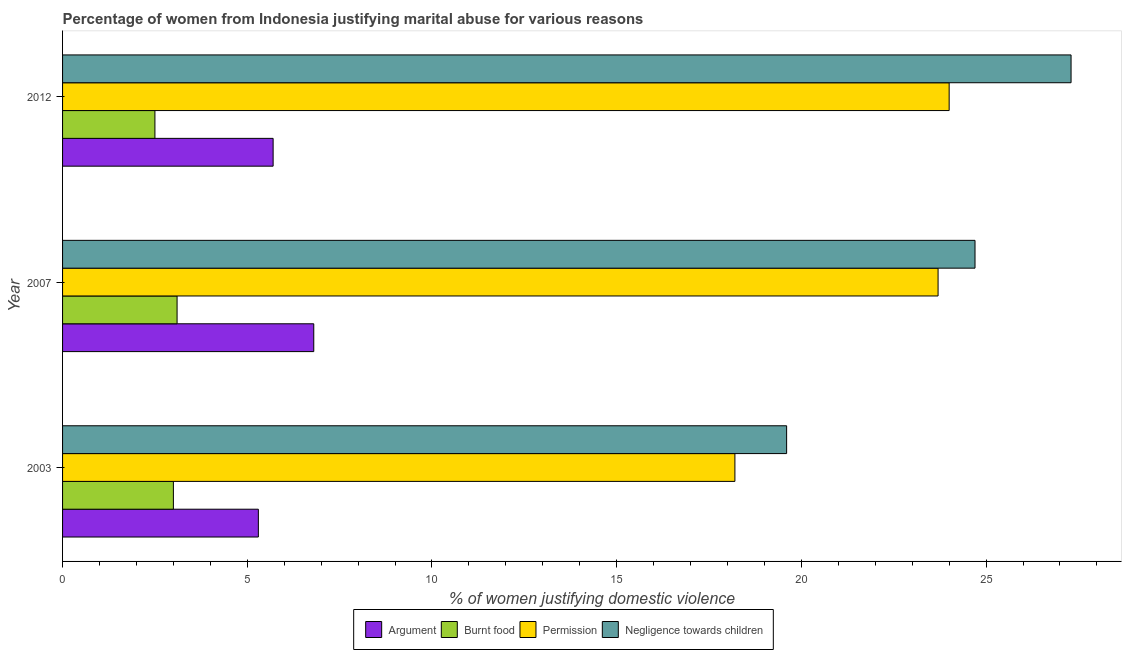How many different coloured bars are there?
Your answer should be compact. 4. Are the number of bars on each tick of the Y-axis equal?
Provide a short and direct response. Yes. What is the percentage of women justifying abuse in the case of an argument in 2012?
Make the answer very short. 5.7. Across all years, what is the maximum percentage of women justifying abuse for showing negligence towards children?
Provide a short and direct response. 27.3. Across all years, what is the minimum percentage of women justifying abuse for showing negligence towards children?
Give a very brief answer. 19.6. In which year was the percentage of women justifying abuse for burning food maximum?
Give a very brief answer. 2007. In which year was the percentage of women justifying abuse for going without permission minimum?
Provide a succinct answer. 2003. What is the total percentage of women justifying abuse for showing negligence towards children in the graph?
Offer a very short reply. 71.6. What is the difference between the percentage of women justifying abuse in the case of an argument in 2003 and that in 2007?
Your answer should be very brief. -1.5. What is the average percentage of women justifying abuse for burning food per year?
Offer a very short reply. 2.87. In the year 2007, what is the difference between the percentage of women justifying abuse in the case of an argument and percentage of women justifying abuse for going without permission?
Provide a short and direct response. -16.9. What is the ratio of the percentage of women justifying abuse for showing negligence towards children in 2003 to that in 2007?
Ensure brevity in your answer.  0.79. Is the difference between the percentage of women justifying abuse for showing negligence towards children in 2003 and 2007 greater than the difference between the percentage of women justifying abuse in the case of an argument in 2003 and 2007?
Your answer should be very brief. No. What is the difference between the highest and the second highest percentage of women justifying abuse in the case of an argument?
Give a very brief answer. 1.1. What is the difference between the highest and the lowest percentage of women justifying abuse for showing negligence towards children?
Provide a short and direct response. 7.7. In how many years, is the percentage of women justifying abuse in the case of an argument greater than the average percentage of women justifying abuse in the case of an argument taken over all years?
Offer a very short reply. 1. Is the sum of the percentage of women justifying abuse for going without permission in 2007 and 2012 greater than the maximum percentage of women justifying abuse in the case of an argument across all years?
Offer a terse response. Yes. What does the 3rd bar from the top in 2012 represents?
Keep it short and to the point. Burnt food. What does the 2nd bar from the bottom in 2003 represents?
Keep it short and to the point. Burnt food. Is it the case that in every year, the sum of the percentage of women justifying abuse in the case of an argument and percentage of women justifying abuse for burning food is greater than the percentage of women justifying abuse for going without permission?
Make the answer very short. No. How many bars are there?
Offer a very short reply. 12. Are all the bars in the graph horizontal?
Your response must be concise. Yes. Are the values on the major ticks of X-axis written in scientific E-notation?
Make the answer very short. No. Does the graph contain grids?
Your answer should be compact. No. Where does the legend appear in the graph?
Offer a terse response. Bottom center. What is the title of the graph?
Ensure brevity in your answer.  Percentage of women from Indonesia justifying marital abuse for various reasons. What is the label or title of the X-axis?
Make the answer very short. % of women justifying domestic violence. What is the % of women justifying domestic violence in Permission in 2003?
Your response must be concise. 18.2. What is the % of women justifying domestic violence in Negligence towards children in 2003?
Your response must be concise. 19.6. What is the % of women justifying domestic violence in Argument in 2007?
Keep it short and to the point. 6.8. What is the % of women justifying domestic violence in Permission in 2007?
Offer a terse response. 23.7. What is the % of women justifying domestic violence in Negligence towards children in 2007?
Keep it short and to the point. 24.7. What is the % of women justifying domestic violence in Permission in 2012?
Give a very brief answer. 24. What is the % of women justifying domestic violence of Negligence towards children in 2012?
Provide a succinct answer. 27.3. Across all years, what is the maximum % of women justifying domestic violence of Burnt food?
Keep it short and to the point. 3.1. Across all years, what is the maximum % of women justifying domestic violence in Permission?
Offer a very short reply. 24. Across all years, what is the maximum % of women justifying domestic violence in Negligence towards children?
Your response must be concise. 27.3. Across all years, what is the minimum % of women justifying domestic violence of Argument?
Your response must be concise. 5.3. Across all years, what is the minimum % of women justifying domestic violence in Burnt food?
Your response must be concise. 2.5. Across all years, what is the minimum % of women justifying domestic violence of Permission?
Provide a succinct answer. 18.2. Across all years, what is the minimum % of women justifying domestic violence in Negligence towards children?
Offer a very short reply. 19.6. What is the total % of women justifying domestic violence of Burnt food in the graph?
Give a very brief answer. 8.6. What is the total % of women justifying domestic violence in Permission in the graph?
Your response must be concise. 65.9. What is the total % of women justifying domestic violence of Negligence towards children in the graph?
Provide a succinct answer. 71.6. What is the difference between the % of women justifying domestic violence of Burnt food in 2003 and that in 2007?
Your answer should be compact. -0.1. What is the difference between the % of women justifying domestic violence in Negligence towards children in 2003 and that in 2007?
Your answer should be compact. -5.1. What is the difference between the % of women justifying domestic violence in Permission in 2003 and that in 2012?
Offer a terse response. -5.8. What is the difference between the % of women justifying domestic violence of Argument in 2007 and that in 2012?
Provide a short and direct response. 1.1. What is the difference between the % of women justifying domestic violence of Burnt food in 2007 and that in 2012?
Your answer should be compact. 0.6. What is the difference between the % of women justifying domestic violence in Permission in 2007 and that in 2012?
Offer a very short reply. -0.3. What is the difference between the % of women justifying domestic violence in Argument in 2003 and the % of women justifying domestic violence in Burnt food in 2007?
Your answer should be compact. 2.2. What is the difference between the % of women justifying domestic violence of Argument in 2003 and the % of women justifying domestic violence of Permission in 2007?
Keep it short and to the point. -18.4. What is the difference between the % of women justifying domestic violence in Argument in 2003 and the % of women justifying domestic violence in Negligence towards children in 2007?
Ensure brevity in your answer.  -19.4. What is the difference between the % of women justifying domestic violence of Burnt food in 2003 and the % of women justifying domestic violence of Permission in 2007?
Your answer should be compact. -20.7. What is the difference between the % of women justifying domestic violence in Burnt food in 2003 and the % of women justifying domestic violence in Negligence towards children in 2007?
Ensure brevity in your answer.  -21.7. What is the difference between the % of women justifying domestic violence in Permission in 2003 and the % of women justifying domestic violence in Negligence towards children in 2007?
Offer a very short reply. -6.5. What is the difference between the % of women justifying domestic violence in Argument in 2003 and the % of women justifying domestic violence in Permission in 2012?
Provide a succinct answer. -18.7. What is the difference between the % of women justifying domestic violence in Argument in 2003 and the % of women justifying domestic violence in Negligence towards children in 2012?
Provide a short and direct response. -22. What is the difference between the % of women justifying domestic violence in Burnt food in 2003 and the % of women justifying domestic violence in Negligence towards children in 2012?
Keep it short and to the point. -24.3. What is the difference between the % of women justifying domestic violence of Argument in 2007 and the % of women justifying domestic violence of Permission in 2012?
Give a very brief answer. -17.2. What is the difference between the % of women justifying domestic violence in Argument in 2007 and the % of women justifying domestic violence in Negligence towards children in 2012?
Offer a very short reply. -20.5. What is the difference between the % of women justifying domestic violence of Burnt food in 2007 and the % of women justifying domestic violence of Permission in 2012?
Ensure brevity in your answer.  -20.9. What is the difference between the % of women justifying domestic violence of Burnt food in 2007 and the % of women justifying domestic violence of Negligence towards children in 2012?
Your response must be concise. -24.2. What is the difference between the % of women justifying domestic violence of Permission in 2007 and the % of women justifying domestic violence of Negligence towards children in 2012?
Your answer should be compact. -3.6. What is the average % of women justifying domestic violence of Argument per year?
Ensure brevity in your answer.  5.93. What is the average % of women justifying domestic violence in Burnt food per year?
Your response must be concise. 2.87. What is the average % of women justifying domestic violence in Permission per year?
Make the answer very short. 21.97. What is the average % of women justifying domestic violence of Negligence towards children per year?
Provide a short and direct response. 23.87. In the year 2003, what is the difference between the % of women justifying domestic violence in Argument and % of women justifying domestic violence in Permission?
Offer a very short reply. -12.9. In the year 2003, what is the difference between the % of women justifying domestic violence of Argument and % of women justifying domestic violence of Negligence towards children?
Your answer should be very brief. -14.3. In the year 2003, what is the difference between the % of women justifying domestic violence of Burnt food and % of women justifying domestic violence of Permission?
Ensure brevity in your answer.  -15.2. In the year 2003, what is the difference between the % of women justifying domestic violence in Burnt food and % of women justifying domestic violence in Negligence towards children?
Keep it short and to the point. -16.6. In the year 2007, what is the difference between the % of women justifying domestic violence of Argument and % of women justifying domestic violence of Permission?
Provide a short and direct response. -16.9. In the year 2007, what is the difference between the % of women justifying domestic violence in Argument and % of women justifying domestic violence in Negligence towards children?
Ensure brevity in your answer.  -17.9. In the year 2007, what is the difference between the % of women justifying domestic violence of Burnt food and % of women justifying domestic violence of Permission?
Your answer should be very brief. -20.6. In the year 2007, what is the difference between the % of women justifying domestic violence in Burnt food and % of women justifying domestic violence in Negligence towards children?
Your response must be concise. -21.6. In the year 2007, what is the difference between the % of women justifying domestic violence of Permission and % of women justifying domestic violence of Negligence towards children?
Your answer should be very brief. -1. In the year 2012, what is the difference between the % of women justifying domestic violence in Argument and % of women justifying domestic violence in Burnt food?
Your answer should be compact. 3.2. In the year 2012, what is the difference between the % of women justifying domestic violence of Argument and % of women justifying domestic violence of Permission?
Your response must be concise. -18.3. In the year 2012, what is the difference between the % of women justifying domestic violence of Argument and % of women justifying domestic violence of Negligence towards children?
Your answer should be compact. -21.6. In the year 2012, what is the difference between the % of women justifying domestic violence of Burnt food and % of women justifying domestic violence of Permission?
Ensure brevity in your answer.  -21.5. In the year 2012, what is the difference between the % of women justifying domestic violence in Burnt food and % of women justifying domestic violence in Negligence towards children?
Provide a short and direct response. -24.8. In the year 2012, what is the difference between the % of women justifying domestic violence in Permission and % of women justifying domestic violence in Negligence towards children?
Make the answer very short. -3.3. What is the ratio of the % of women justifying domestic violence of Argument in 2003 to that in 2007?
Ensure brevity in your answer.  0.78. What is the ratio of the % of women justifying domestic violence of Burnt food in 2003 to that in 2007?
Offer a very short reply. 0.97. What is the ratio of the % of women justifying domestic violence in Permission in 2003 to that in 2007?
Provide a succinct answer. 0.77. What is the ratio of the % of women justifying domestic violence in Negligence towards children in 2003 to that in 2007?
Keep it short and to the point. 0.79. What is the ratio of the % of women justifying domestic violence in Argument in 2003 to that in 2012?
Offer a terse response. 0.93. What is the ratio of the % of women justifying domestic violence in Permission in 2003 to that in 2012?
Ensure brevity in your answer.  0.76. What is the ratio of the % of women justifying domestic violence of Negligence towards children in 2003 to that in 2012?
Your answer should be compact. 0.72. What is the ratio of the % of women justifying domestic violence in Argument in 2007 to that in 2012?
Keep it short and to the point. 1.19. What is the ratio of the % of women justifying domestic violence of Burnt food in 2007 to that in 2012?
Your answer should be very brief. 1.24. What is the ratio of the % of women justifying domestic violence of Permission in 2007 to that in 2012?
Your answer should be compact. 0.99. What is the ratio of the % of women justifying domestic violence of Negligence towards children in 2007 to that in 2012?
Offer a terse response. 0.9. What is the difference between the highest and the second highest % of women justifying domestic violence of Argument?
Your answer should be very brief. 1.1. What is the difference between the highest and the second highest % of women justifying domestic violence of Burnt food?
Ensure brevity in your answer.  0.1. What is the difference between the highest and the lowest % of women justifying domestic violence in Argument?
Give a very brief answer. 1.5. What is the difference between the highest and the lowest % of women justifying domestic violence of Burnt food?
Provide a succinct answer. 0.6. What is the difference between the highest and the lowest % of women justifying domestic violence in Permission?
Your answer should be very brief. 5.8. 